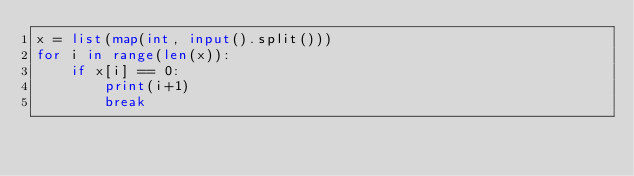Convert code to text. <code><loc_0><loc_0><loc_500><loc_500><_Python_>x = list(map(int, input().split()))
for i in range(len(x)):
    if x[i] == 0:
        print(i+1)
        break
</code> 